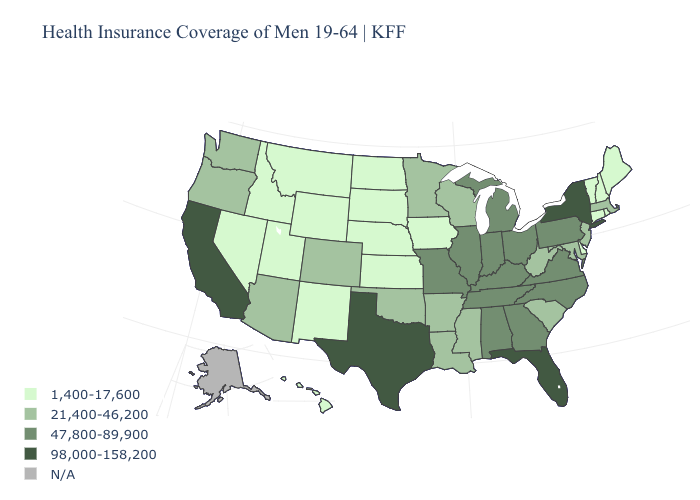Name the states that have a value in the range 21,400-46,200?
Give a very brief answer. Arizona, Arkansas, Colorado, Louisiana, Maryland, Massachusetts, Minnesota, Mississippi, New Jersey, Oklahoma, Oregon, South Carolina, Washington, West Virginia, Wisconsin. Name the states that have a value in the range N/A?
Keep it brief. Alaska. What is the highest value in states that border Louisiana?
Be succinct. 98,000-158,200. Which states hav the highest value in the West?
Concise answer only. California. Which states have the lowest value in the USA?
Give a very brief answer. Connecticut, Delaware, Hawaii, Idaho, Iowa, Kansas, Maine, Montana, Nebraska, Nevada, New Hampshire, New Mexico, North Dakota, Rhode Island, South Dakota, Utah, Vermont, Wyoming. Among the states that border Ohio , does Pennsylvania have the highest value?
Concise answer only. Yes. Does North Dakota have the highest value in the MidWest?
Quick response, please. No. What is the highest value in the South ?
Short answer required. 98,000-158,200. Is the legend a continuous bar?
Write a very short answer. No. Name the states that have a value in the range 21,400-46,200?
Keep it brief. Arizona, Arkansas, Colorado, Louisiana, Maryland, Massachusetts, Minnesota, Mississippi, New Jersey, Oklahoma, Oregon, South Carolina, Washington, West Virginia, Wisconsin. What is the value of Montana?
Give a very brief answer. 1,400-17,600. What is the value of Maine?
Answer briefly. 1,400-17,600. What is the value of New Mexico?
Keep it brief. 1,400-17,600. Does Florida have the lowest value in the South?
Answer briefly. No. What is the highest value in the South ?
Short answer required. 98,000-158,200. 